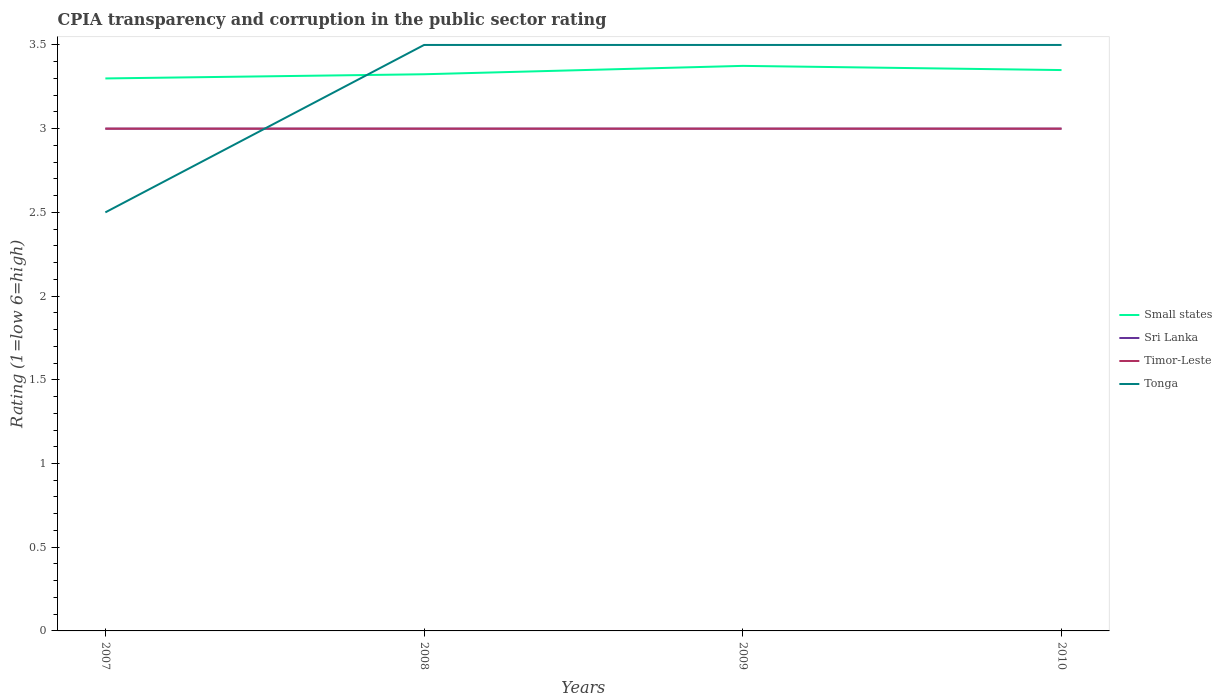How many different coloured lines are there?
Provide a succinct answer. 4. Is the number of lines equal to the number of legend labels?
Give a very brief answer. Yes. What is the difference between the highest and the lowest CPIA rating in Small states?
Give a very brief answer. 2. Is the CPIA rating in Timor-Leste strictly greater than the CPIA rating in Small states over the years?
Make the answer very short. Yes. What is the difference between two consecutive major ticks on the Y-axis?
Make the answer very short. 0.5. Are the values on the major ticks of Y-axis written in scientific E-notation?
Your answer should be very brief. No. Where does the legend appear in the graph?
Keep it short and to the point. Center right. How many legend labels are there?
Make the answer very short. 4. What is the title of the graph?
Provide a succinct answer. CPIA transparency and corruption in the public sector rating. Does "Guyana" appear as one of the legend labels in the graph?
Provide a succinct answer. No. What is the label or title of the X-axis?
Give a very brief answer. Years. What is the Rating (1=low 6=high) of Small states in 2008?
Keep it short and to the point. 3.33. What is the Rating (1=low 6=high) in Sri Lanka in 2008?
Provide a succinct answer. 3. What is the Rating (1=low 6=high) of Timor-Leste in 2008?
Make the answer very short. 3. What is the Rating (1=low 6=high) in Small states in 2009?
Ensure brevity in your answer.  3.38. What is the Rating (1=low 6=high) of Timor-Leste in 2009?
Your answer should be very brief. 3. What is the Rating (1=low 6=high) of Small states in 2010?
Offer a very short reply. 3.35. What is the Rating (1=low 6=high) in Timor-Leste in 2010?
Provide a succinct answer. 3. Across all years, what is the maximum Rating (1=low 6=high) of Small states?
Keep it short and to the point. 3.38. Across all years, what is the maximum Rating (1=low 6=high) in Sri Lanka?
Your response must be concise. 3. Across all years, what is the minimum Rating (1=low 6=high) of Sri Lanka?
Your answer should be compact. 3. Across all years, what is the minimum Rating (1=low 6=high) of Timor-Leste?
Offer a terse response. 3. What is the total Rating (1=low 6=high) of Small states in the graph?
Your answer should be compact. 13.35. What is the total Rating (1=low 6=high) in Tonga in the graph?
Offer a very short reply. 13. What is the difference between the Rating (1=low 6=high) in Small states in 2007 and that in 2008?
Offer a terse response. -0.03. What is the difference between the Rating (1=low 6=high) in Sri Lanka in 2007 and that in 2008?
Provide a succinct answer. 0. What is the difference between the Rating (1=low 6=high) of Small states in 2007 and that in 2009?
Your response must be concise. -0.07. What is the difference between the Rating (1=low 6=high) in Sri Lanka in 2007 and that in 2009?
Provide a short and direct response. 0. What is the difference between the Rating (1=low 6=high) in Sri Lanka in 2007 and that in 2010?
Offer a terse response. 0. What is the difference between the Rating (1=low 6=high) in Timor-Leste in 2007 and that in 2010?
Offer a terse response. 0. What is the difference between the Rating (1=low 6=high) of Tonga in 2007 and that in 2010?
Provide a short and direct response. -1. What is the difference between the Rating (1=low 6=high) of Timor-Leste in 2008 and that in 2009?
Offer a very short reply. 0. What is the difference between the Rating (1=low 6=high) of Tonga in 2008 and that in 2009?
Ensure brevity in your answer.  0. What is the difference between the Rating (1=low 6=high) in Small states in 2008 and that in 2010?
Offer a terse response. -0.03. What is the difference between the Rating (1=low 6=high) in Sri Lanka in 2008 and that in 2010?
Provide a short and direct response. 0. What is the difference between the Rating (1=low 6=high) of Small states in 2009 and that in 2010?
Your answer should be very brief. 0.03. What is the difference between the Rating (1=low 6=high) in Sri Lanka in 2009 and that in 2010?
Keep it short and to the point. 0. What is the difference between the Rating (1=low 6=high) in Timor-Leste in 2009 and that in 2010?
Your answer should be very brief. 0. What is the difference between the Rating (1=low 6=high) in Tonga in 2009 and that in 2010?
Make the answer very short. 0. What is the difference between the Rating (1=low 6=high) of Small states in 2007 and the Rating (1=low 6=high) of Sri Lanka in 2008?
Give a very brief answer. 0.3. What is the difference between the Rating (1=low 6=high) of Small states in 2007 and the Rating (1=low 6=high) of Timor-Leste in 2008?
Provide a succinct answer. 0.3. What is the difference between the Rating (1=low 6=high) of Small states in 2007 and the Rating (1=low 6=high) of Timor-Leste in 2009?
Ensure brevity in your answer.  0.3. What is the difference between the Rating (1=low 6=high) in Sri Lanka in 2007 and the Rating (1=low 6=high) in Tonga in 2009?
Your answer should be compact. -0.5. What is the difference between the Rating (1=low 6=high) in Timor-Leste in 2007 and the Rating (1=low 6=high) in Tonga in 2009?
Provide a short and direct response. -0.5. What is the difference between the Rating (1=low 6=high) of Small states in 2007 and the Rating (1=low 6=high) of Tonga in 2010?
Give a very brief answer. -0.2. What is the difference between the Rating (1=low 6=high) in Sri Lanka in 2007 and the Rating (1=low 6=high) in Timor-Leste in 2010?
Keep it short and to the point. 0. What is the difference between the Rating (1=low 6=high) of Sri Lanka in 2007 and the Rating (1=low 6=high) of Tonga in 2010?
Your response must be concise. -0.5. What is the difference between the Rating (1=low 6=high) of Timor-Leste in 2007 and the Rating (1=low 6=high) of Tonga in 2010?
Your answer should be very brief. -0.5. What is the difference between the Rating (1=low 6=high) in Small states in 2008 and the Rating (1=low 6=high) in Sri Lanka in 2009?
Provide a succinct answer. 0.33. What is the difference between the Rating (1=low 6=high) of Small states in 2008 and the Rating (1=low 6=high) of Timor-Leste in 2009?
Give a very brief answer. 0.33. What is the difference between the Rating (1=low 6=high) of Small states in 2008 and the Rating (1=low 6=high) of Tonga in 2009?
Give a very brief answer. -0.17. What is the difference between the Rating (1=low 6=high) of Sri Lanka in 2008 and the Rating (1=low 6=high) of Tonga in 2009?
Ensure brevity in your answer.  -0.5. What is the difference between the Rating (1=low 6=high) of Small states in 2008 and the Rating (1=low 6=high) of Sri Lanka in 2010?
Your answer should be very brief. 0.33. What is the difference between the Rating (1=low 6=high) in Small states in 2008 and the Rating (1=low 6=high) in Timor-Leste in 2010?
Keep it short and to the point. 0.33. What is the difference between the Rating (1=low 6=high) of Small states in 2008 and the Rating (1=low 6=high) of Tonga in 2010?
Make the answer very short. -0.17. What is the difference between the Rating (1=low 6=high) in Sri Lanka in 2008 and the Rating (1=low 6=high) in Timor-Leste in 2010?
Offer a very short reply. 0. What is the difference between the Rating (1=low 6=high) of Small states in 2009 and the Rating (1=low 6=high) of Tonga in 2010?
Provide a short and direct response. -0.12. What is the difference between the Rating (1=low 6=high) of Sri Lanka in 2009 and the Rating (1=low 6=high) of Tonga in 2010?
Give a very brief answer. -0.5. What is the average Rating (1=low 6=high) in Small states per year?
Your response must be concise. 3.34. What is the average Rating (1=low 6=high) of Sri Lanka per year?
Provide a short and direct response. 3. What is the average Rating (1=low 6=high) in Timor-Leste per year?
Provide a succinct answer. 3. In the year 2007, what is the difference between the Rating (1=low 6=high) of Small states and Rating (1=low 6=high) of Sri Lanka?
Ensure brevity in your answer.  0.3. In the year 2007, what is the difference between the Rating (1=low 6=high) of Small states and Rating (1=low 6=high) of Tonga?
Offer a very short reply. 0.8. In the year 2007, what is the difference between the Rating (1=low 6=high) of Timor-Leste and Rating (1=low 6=high) of Tonga?
Give a very brief answer. 0.5. In the year 2008, what is the difference between the Rating (1=low 6=high) in Small states and Rating (1=low 6=high) in Sri Lanka?
Provide a short and direct response. 0.33. In the year 2008, what is the difference between the Rating (1=low 6=high) in Small states and Rating (1=low 6=high) in Timor-Leste?
Keep it short and to the point. 0.33. In the year 2008, what is the difference between the Rating (1=low 6=high) of Small states and Rating (1=low 6=high) of Tonga?
Your answer should be compact. -0.17. In the year 2008, what is the difference between the Rating (1=low 6=high) in Sri Lanka and Rating (1=low 6=high) in Timor-Leste?
Your answer should be compact. 0. In the year 2009, what is the difference between the Rating (1=low 6=high) in Small states and Rating (1=low 6=high) in Sri Lanka?
Offer a very short reply. 0.38. In the year 2009, what is the difference between the Rating (1=low 6=high) in Small states and Rating (1=low 6=high) in Timor-Leste?
Make the answer very short. 0.38. In the year 2009, what is the difference between the Rating (1=low 6=high) of Small states and Rating (1=low 6=high) of Tonga?
Your response must be concise. -0.12. In the year 2010, what is the difference between the Rating (1=low 6=high) in Small states and Rating (1=low 6=high) in Sri Lanka?
Offer a terse response. 0.35. In the year 2010, what is the difference between the Rating (1=low 6=high) of Sri Lanka and Rating (1=low 6=high) of Tonga?
Offer a very short reply. -0.5. In the year 2010, what is the difference between the Rating (1=low 6=high) of Timor-Leste and Rating (1=low 6=high) of Tonga?
Provide a succinct answer. -0.5. What is the ratio of the Rating (1=low 6=high) of Small states in 2007 to that in 2008?
Give a very brief answer. 0.99. What is the ratio of the Rating (1=low 6=high) of Sri Lanka in 2007 to that in 2008?
Make the answer very short. 1. What is the ratio of the Rating (1=low 6=high) of Tonga in 2007 to that in 2008?
Make the answer very short. 0.71. What is the ratio of the Rating (1=low 6=high) of Small states in 2007 to that in 2009?
Your answer should be very brief. 0.98. What is the ratio of the Rating (1=low 6=high) of Timor-Leste in 2007 to that in 2009?
Your answer should be very brief. 1. What is the ratio of the Rating (1=low 6=high) of Tonga in 2007 to that in 2009?
Make the answer very short. 0.71. What is the ratio of the Rating (1=low 6=high) in Small states in 2007 to that in 2010?
Make the answer very short. 0.99. What is the ratio of the Rating (1=low 6=high) in Tonga in 2007 to that in 2010?
Your response must be concise. 0.71. What is the ratio of the Rating (1=low 6=high) of Small states in 2008 to that in 2009?
Offer a very short reply. 0.99. What is the ratio of the Rating (1=low 6=high) in Sri Lanka in 2008 to that in 2009?
Your response must be concise. 1. What is the ratio of the Rating (1=low 6=high) of Small states in 2008 to that in 2010?
Ensure brevity in your answer.  0.99. What is the ratio of the Rating (1=low 6=high) in Sri Lanka in 2008 to that in 2010?
Provide a succinct answer. 1. What is the ratio of the Rating (1=low 6=high) of Small states in 2009 to that in 2010?
Your answer should be compact. 1.01. What is the difference between the highest and the second highest Rating (1=low 6=high) of Small states?
Provide a succinct answer. 0.03. What is the difference between the highest and the second highest Rating (1=low 6=high) of Timor-Leste?
Offer a terse response. 0. What is the difference between the highest and the lowest Rating (1=low 6=high) in Small states?
Your answer should be compact. 0.07. What is the difference between the highest and the lowest Rating (1=low 6=high) in Timor-Leste?
Offer a very short reply. 0. 